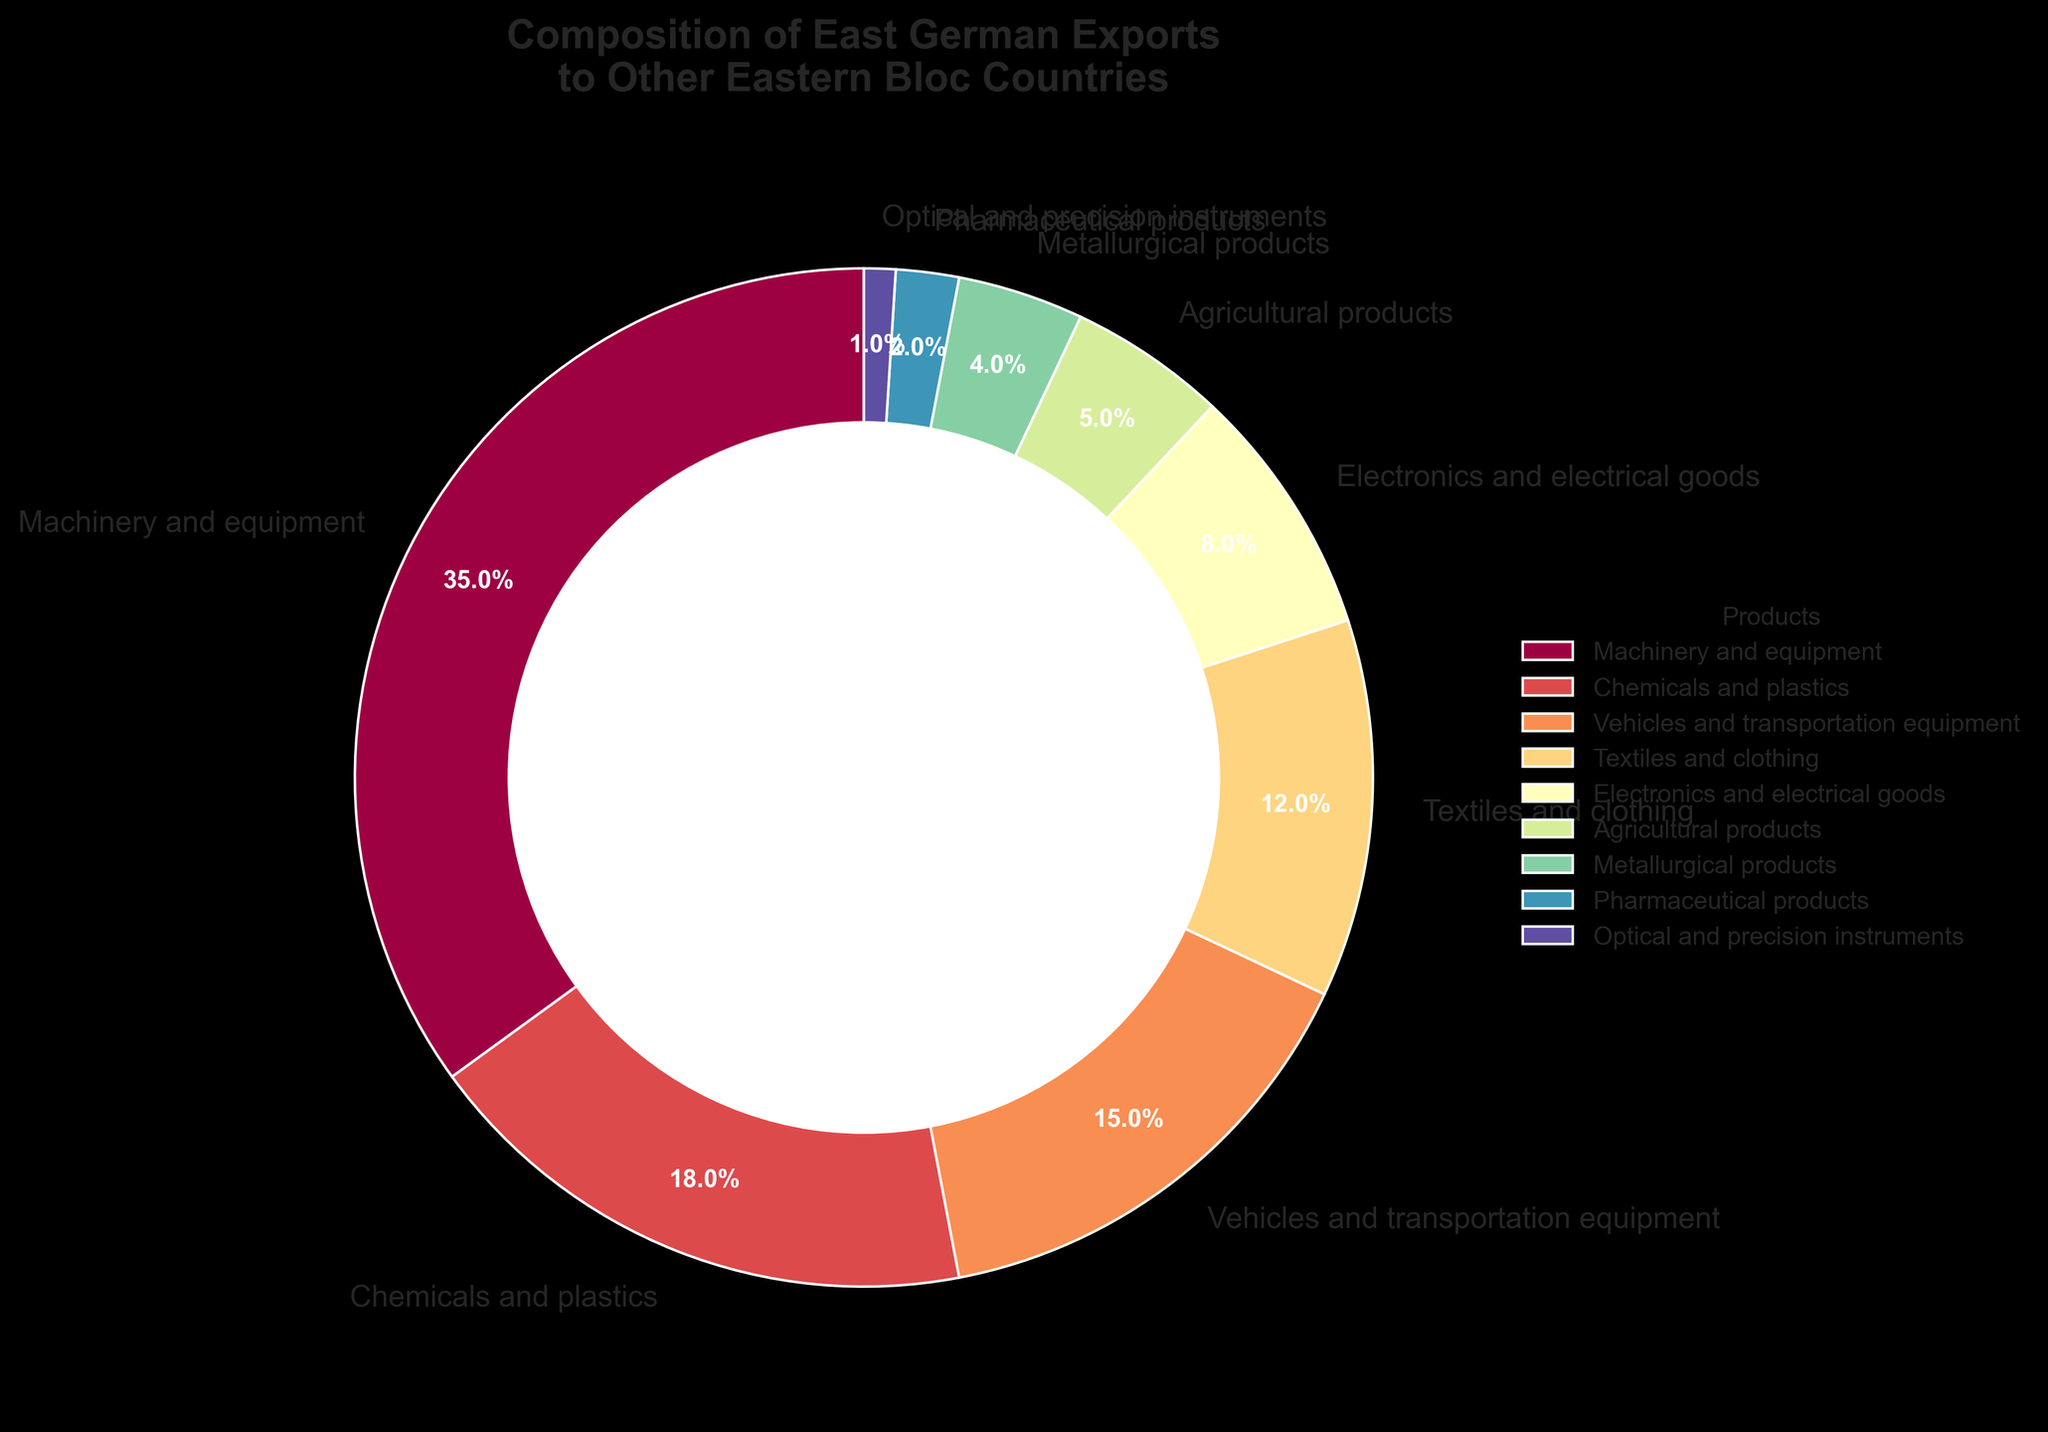What is the percentage of Machinery and equipment exports? The pie chart shows that Machinery and equipment comprise 35% of East German exports to other Eastern Bloc countries.
Answer: 35% Which product category contributes the least to East German exports? The pie chart indicates that Optical and precision instruments make up the smallest percentage at 1%.
Answer: Optical and precision instruments How much higher is the percentage of Chemicals and plastics compared to Electronics and electrical goods? Chemicals and plastics are 18%, and Electronics and electrical goods are 8%, the difference being 18% - 8% = 10%.
Answer: 10% What is the combined percentage of Textiles and clothing, and Agricultural products? Textiles and clothing account for 12%, and Agricultural products 5%. The combined percentage is 12% + 5% = 17%.
Answer: 17% Are Vehicles and transportation equipment exports greater than Agricultural products, and if so, by what percentage? Vehicles and transportation equipment are at 15%, and Agricultural products are at 5%. The difference is 15% - 5% = 10%.
Answer: 10% Do Machinery and equipment, and Chemicals and plastics together constitute more than 50% of exports? Machinery and equipment are 35%, and Chemicals and plastics are 18%. Added together they are 35% + 18% = 53%, which is more than 50%.
Answer: Yes, 53% Which product category has approximately half the percentage of Vehicles and transportation equipment? Vehicles and transportation equipment are 15%. Textiles and clothing are 12%, which is closest but just below half.
Answer: Textiles and clothing Compare the percentage of Metallurgical products and Pharmaceutical products. Which one has a higher export percentage? Metallurgical products are 4%, and Pharmaceutical products are 2%. Metallurgical products have a higher percentage.
Answer: Metallurgical products What is the visual difference in the size of the wedge for Machinery and equipment compared to that of Optical and precision instruments? The wedge for Machinery and equipment (35%) is significantly larger than that for Optical and precision instruments (1%).
Answer: Machinery and equipment wedge is significantly larger If we group the categories into 'Industrial goods' (Machinery and equipment, Chemicals and plastics, Vehicles and transportation equipment, Metaphysical products, and Electronics), what percentage do they collectively make up? Industrial goods include: Machinery and equipment (35%), Chemicals and plastics (18%), Vehicles and transportation equipment (15%), Metallurgical products (4%), and Electronics (8%). Their collective percentage is 35% + 18% + 15% + 4% + 8% = 80%.
Answer: 80% 